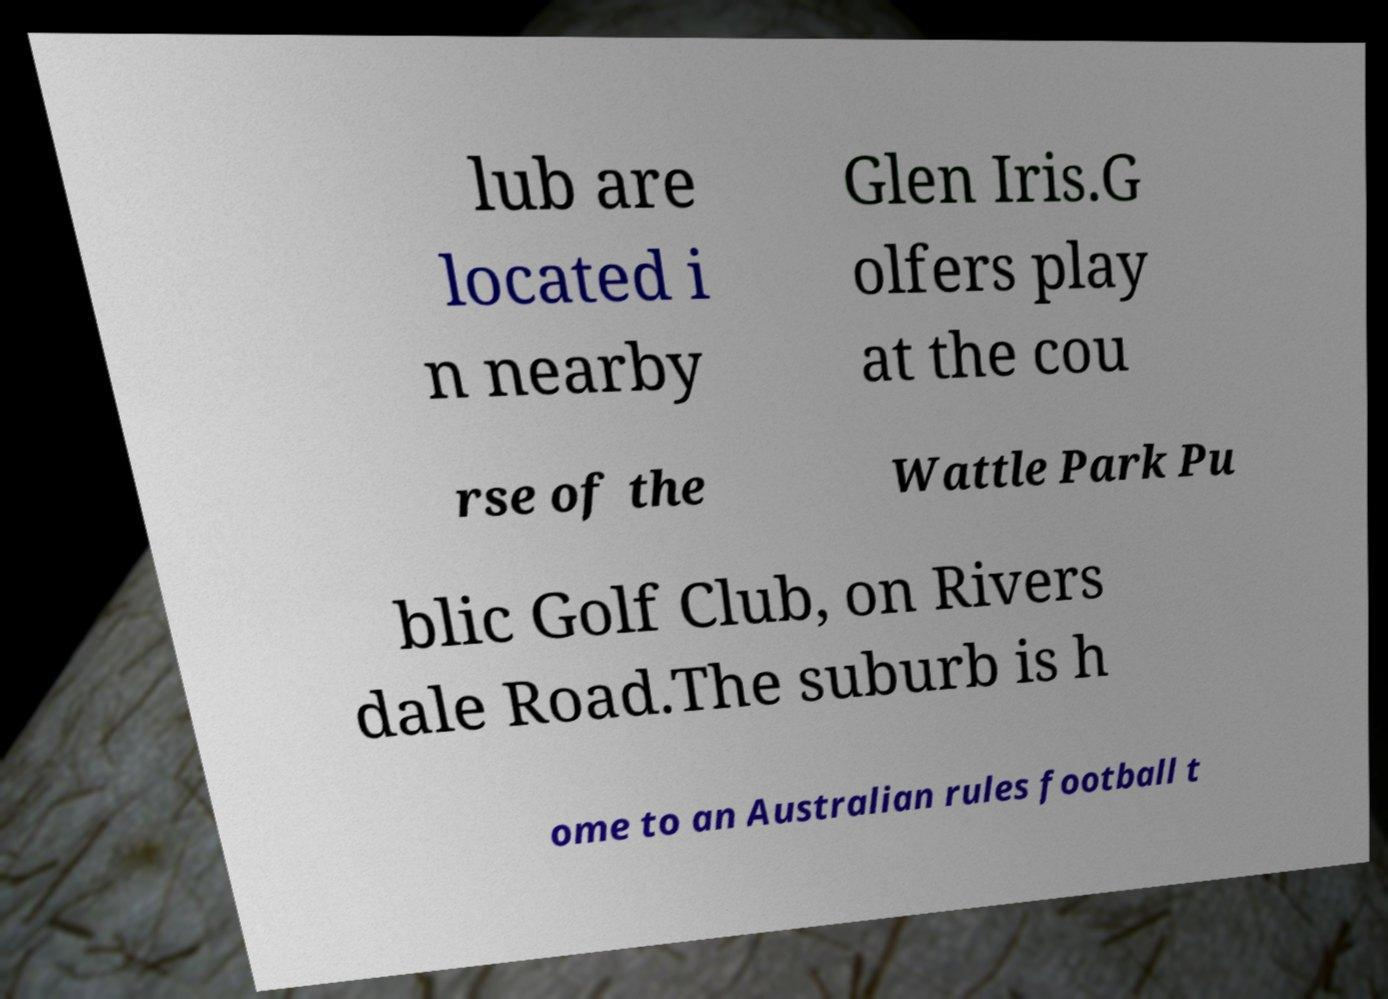Could you extract and type out the text from this image? lub are located i n nearby Glen Iris.G olfers play at the cou rse of the Wattle Park Pu blic Golf Club, on Rivers dale Road.The suburb is h ome to an Australian rules football t 